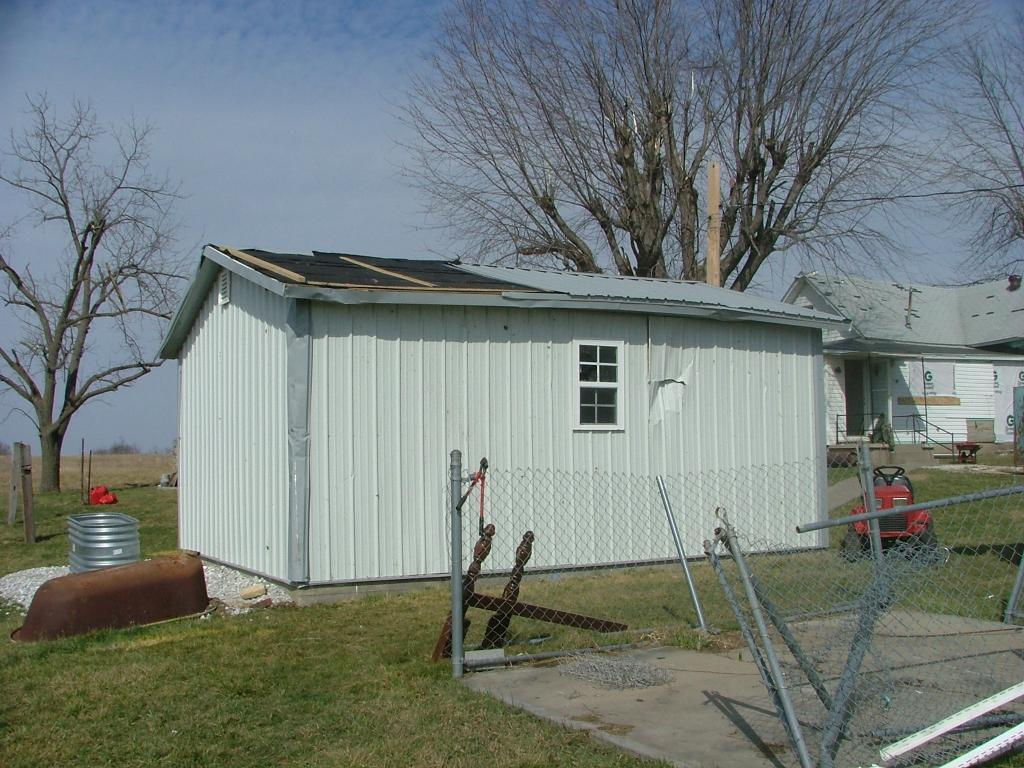What type of structures are visible in the image? There are houses in the image. What type of vegetation is present in the image? There are trees in the image. What type of toy can be seen on the ground in the image? There is a toy car on the ground in the image. What type of barrier is present in the image? There is a metal fence in the image. How would you describe the sky in the image? The sky is blue and cloudy in the image. Can you see a monkey wearing a hat in the image? There is no monkey or hat present in the image. Does the existence of the houses in the image prove the existence of a parallel universe? The existence of houses in the image does not prove the existence of a parallel universe; it simply shows houses in the image. 